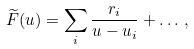Convert formula to latex. <formula><loc_0><loc_0><loc_500><loc_500>\widetilde { F } ( u ) = \sum _ { i } { \frac { r _ { i } } { u - u _ { i } } } + \dots \, ,</formula> 